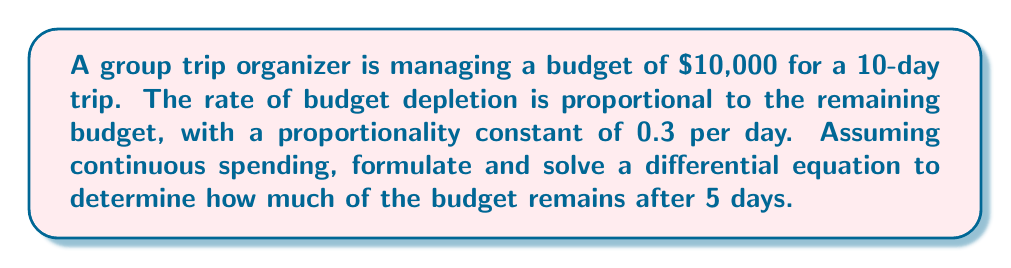Can you answer this question? Let's approach this step-by-step:

1) Let $B(t)$ be the remaining budget at time $t$ (in days).

2) The rate of budget depletion is proportional to the remaining budget. This can be expressed as:

   $$\frac{dB}{dt} = -kB$$

   where $k$ is the proportionality constant (0.3 per day in this case).

3) Rearranging the equation:

   $$\frac{dB}{B} = -k dt$$

4) Integrating both sides:

   $$\int \frac{dB}{B} = -k \int dt$$

   $$\ln|B| = -kt + C$$

5) Solving for $B$:

   $$B = e^{-kt + C} = Ae^{-kt}$$

   where $A = e^C$ is a constant.

6) Using the initial condition: at $t=0$, $B(0) = 10000$

   $$10000 = Ae^{-k(0)} = A$$

7) Therefore, the solution is:

   $$B(t) = 10000e^{-0.3t}$$

8) To find the remaining budget after 5 days, we evaluate $B(5)$:

   $$B(5) = 10000e^{-0.3(5)} = 10000e^{-1.5}$$

9) Calculating this value:

   $$B(5) = 10000 * 0.2231 = 2231$$

Thus, after 5 days, approximately $2,231 of the budget remains.
Answer: $2,231 (rounded to the nearest dollar) 